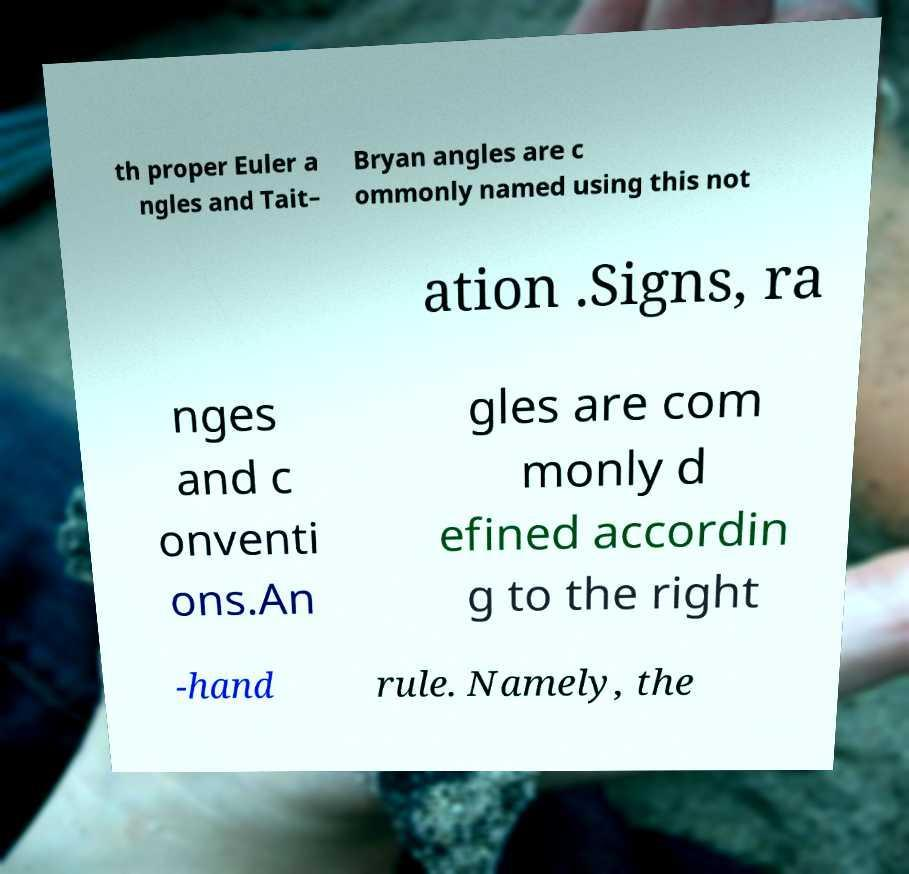Please identify and transcribe the text found in this image. th proper Euler a ngles and Tait– Bryan angles are c ommonly named using this not ation .Signs, ra nges and c onventi ons.An gles are com monly d efined accordin g to the right -hand rule. Namely, the 